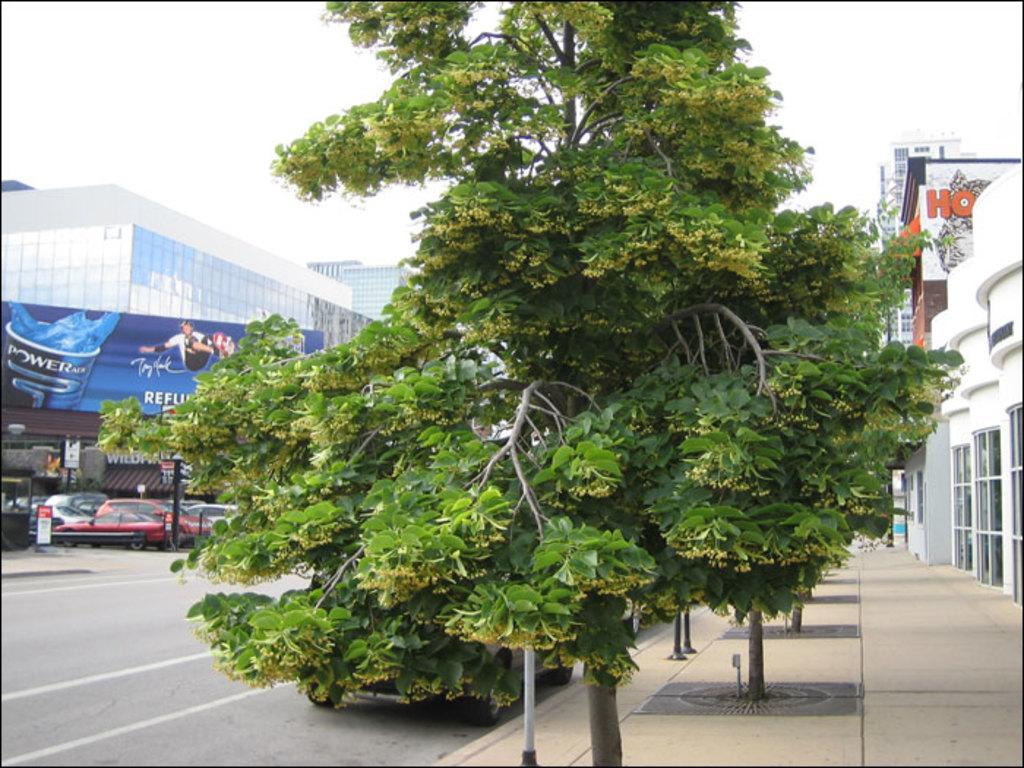In one or two sentences, can you explain what this image depicts? In this image in the front there is a tree. In the background there are cars, trees, buildings and in front of the building there is a boat with some text written on it. On the left side there are buildings and the sky is cloudy. 